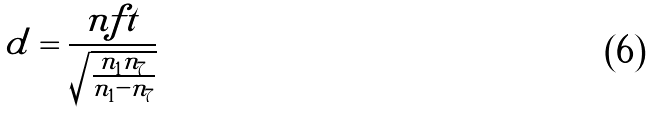Convert formula to latex. <formula><loc_0><loc_0><loc_500><loc_500>\tilde { d } = \frac { n f t } { \sqrt { \frac { n _ { 1 } n _ { 7 } } { n _ { 1 } - n _ { 7 } } } }</formula> 